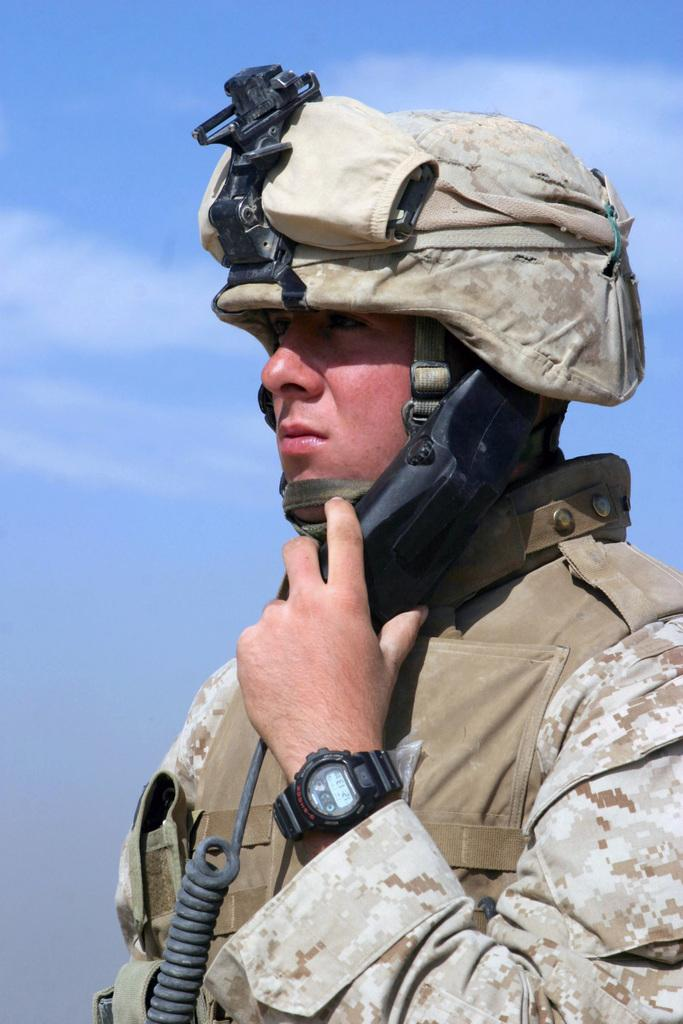Who is present in the image? There is a man in the image. What is the man wearing on his head? The man is wearing a helmet. What accessory is the man wearing on his wrist? The man is wearing a watch. What can be seen in the background of the image? There is sky visible in the background of the image. What type of pipe is the man smoking in the image? There is no pipe present in the image; the man is wearing a helmet and a watch. Is the man wearing a scarf in the image? The provided facts do not mention a scarf, so we cannot determine if the man is wearing one in the image. 